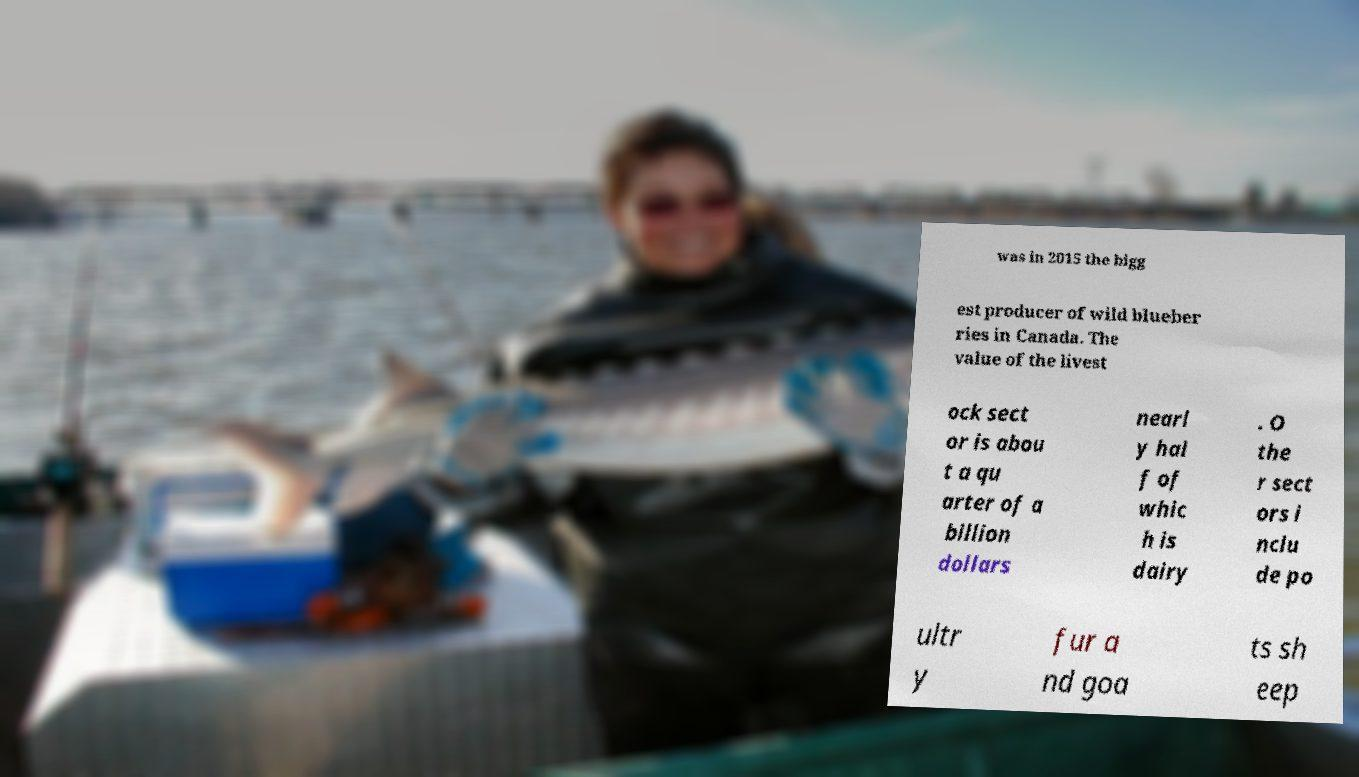There's text embedded in this image that I need extracted. Can you transcribe it verbatim? was in 2015 the bigg est producer of wild blueber ries in Canada. The value of the livest ock sect or is abou t a qu arter of a billion dollars nearl y hal f of whic h is dairy . O the r sect ors i nclu de po ultr y fur a nd goa ts sh eep 